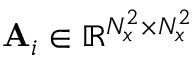Convert formula to latex. <formula><loc_0><loc_0><loc_500><loc_500>A _ { i } \in \mathbb { R } ^ { N _ { x } ^ { 2 } \times N _ { x } ^ { 2 } }</formula> 